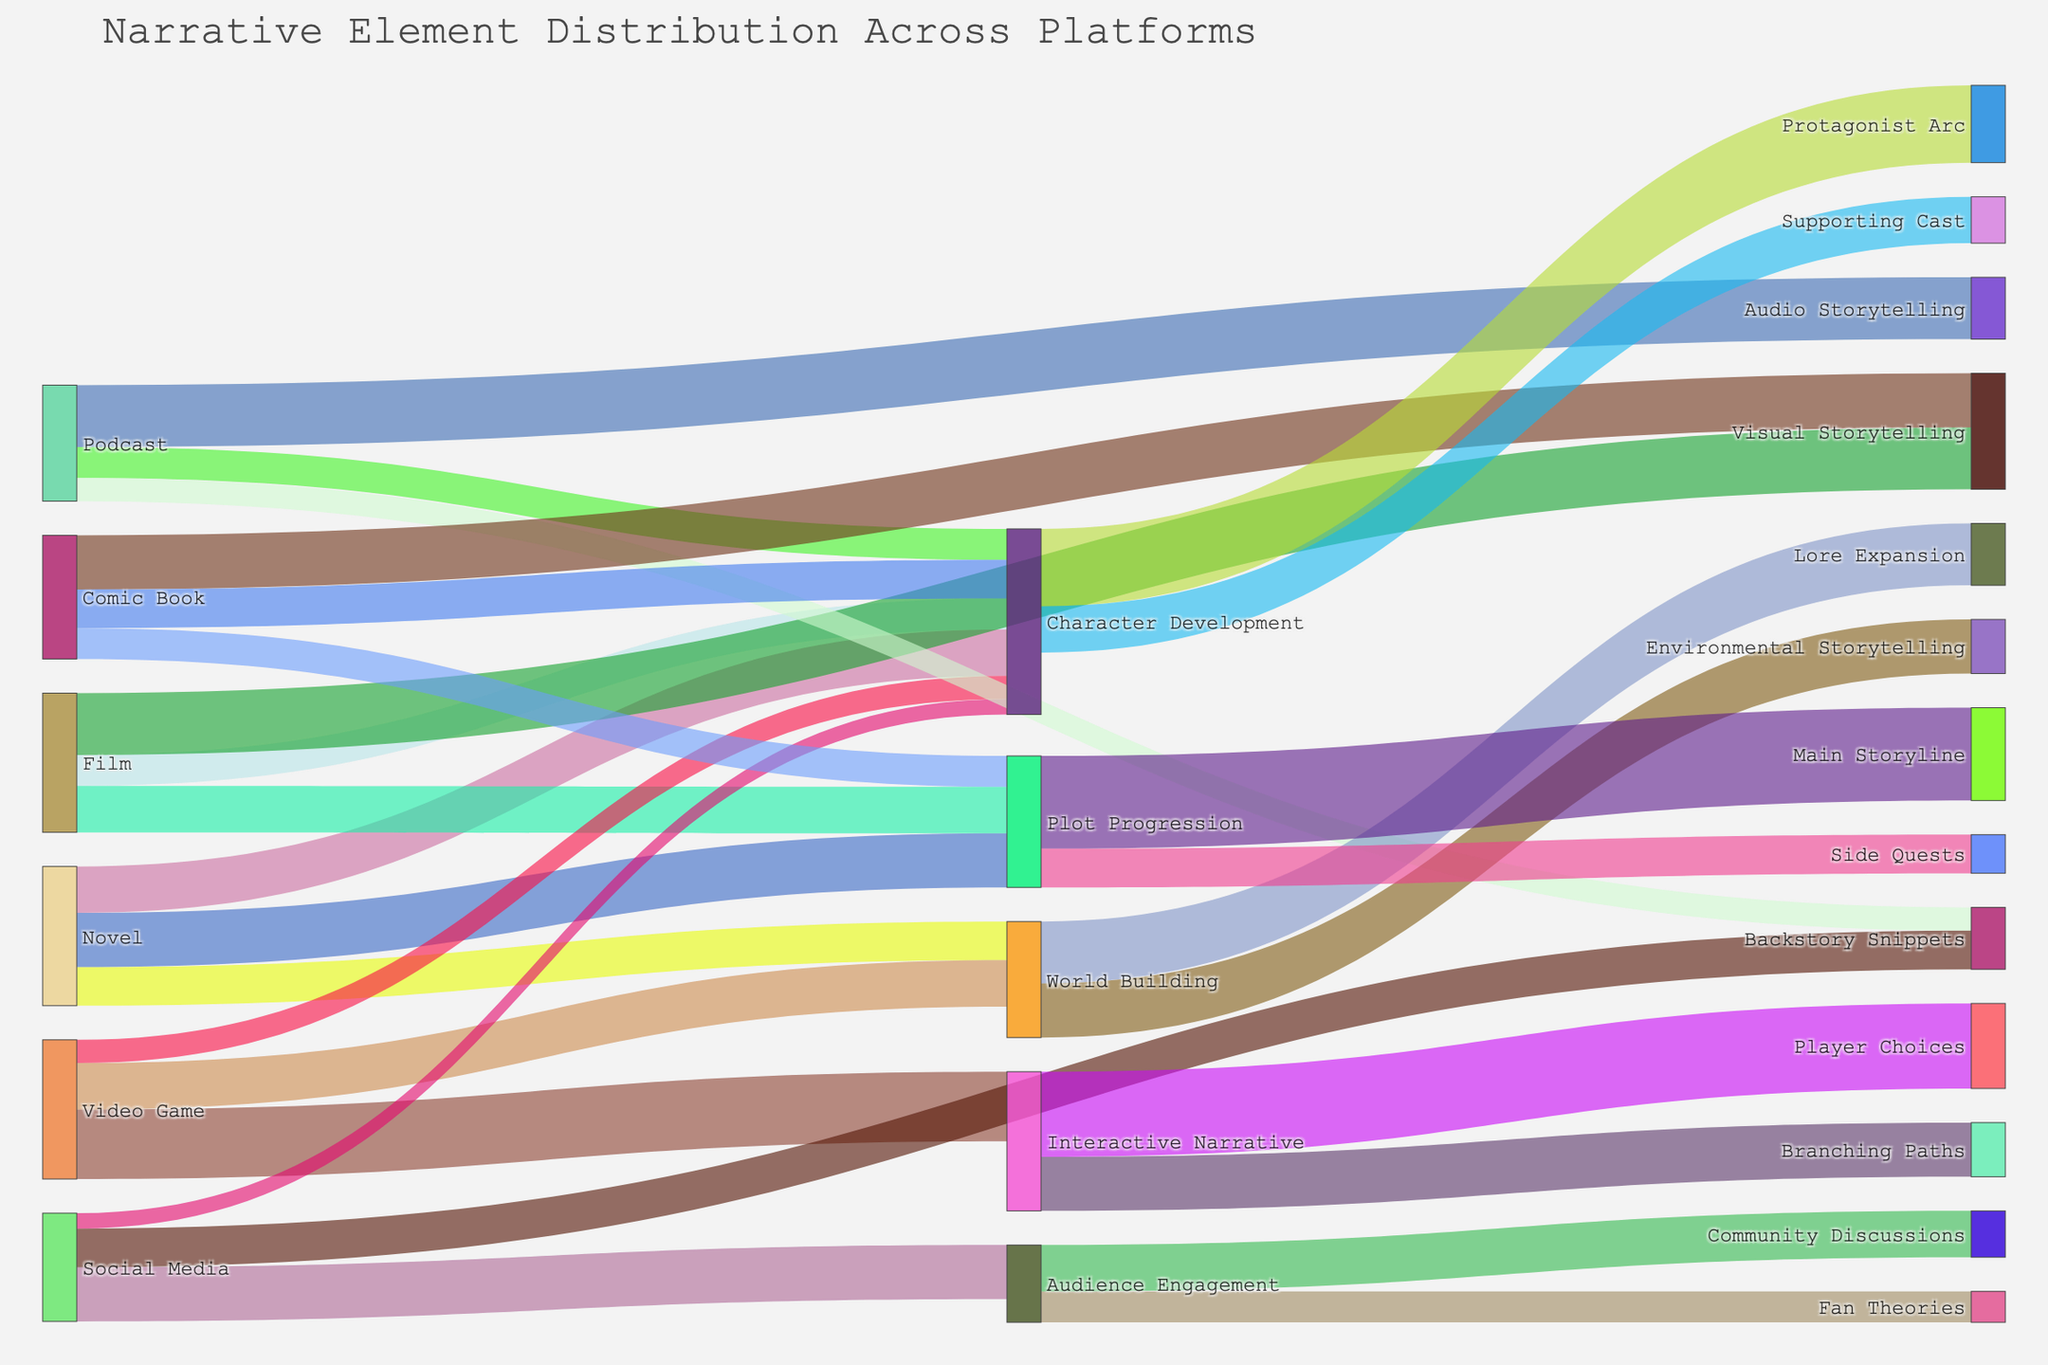What is the title of the Sankey Diagram? The title of the diagram is typically displayed at the top or within the main area of the plot. In this case, it indicates the overall purpose or focus of the visualization.
Answer: Narrative Element Distribution Across Platforms Which platforms prominently contribute to Character Development? By tracing the connections leading to Character Development, one can see all primary sources. The platforms contributing prominently are Novel, Film, Video Game, Social Media, Podcast, and Comic Book.
Answer: Novel, Film, Video Game, Social Media, Podcast, Comic Book What is the combined value of Character Development contributions from Novels and Films? By locating the values of the links from Novel to Character Development (30) and Film to Character Development (20), and summing them up, the calculation gives 30 + 20.
Answer: 50 How do the contributions to Plot Progression from Novels and Films compare? By comparing the values, we see that the Novel to Plot Progression link is 35, and the Film to Plot Progression link is 30. Therefore, the Novel contributes more to Plot Progression.
Answer: Novel contributes more Which platform has the highest value contribution to Visual Storytelling? Visual Storytelling is associated with two platforms: Film and Comic Book. By comparing their values, Film contributes 40, while Comic Book contributes 35. The highest value is thus from Film.
Answer: Film What is the value difference between Interactive Narrative and Player Choices vs. Branching Paths? The values associated are 55 for Player Choices and 35 for Branching Paths. Subtracting these values gives 55 - 35.
Answer: 20 What are the distinct narrative elements derived from Interactive Narrative? By following the target connections from Interactive Narrative, they lead to Player Choices and Branching Paths.
Answer: Player Choices, Branching Paths What is the total value for Audience Engagement? Adding the values associated with Audience Engagement: 35 (from Social Media) + 20 (Fan Theories) + 30 (Community Discussions).
Answer: 85 Which narrative element stemming from Character Development has the highest value? By observing the target connections from Character Development, the values are associated with Protagonist Arc (50) and Supporting Cast (30). Protagonist Arc has the higher value.
Answer: Protagonist Arc How many types of storytelling techniques are derived from the Podcast platform? By tracing the connections from the Podcast platform, the narrative elements are Character Development, Audio Storytelling, and Backstory Snippets, which makes three distinct storytelling techniques derived.
Answer: Three 